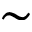<formula> <loc_0><loc_0><loc_500><loc_500>\sim</formula> 